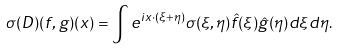Convert formula to latex. <formula><loc_0><loc_0><loc_500><loc_500>\sigma ( D ) ( f , g ) ( x ) = \int e ^ { i x \cdot ( \xi + \eta ) } \sigma ( \xi , \eta ) \hat { f } ( \xi ) \hat { g } ( \eta ) d \xi d \eta .</formula> 